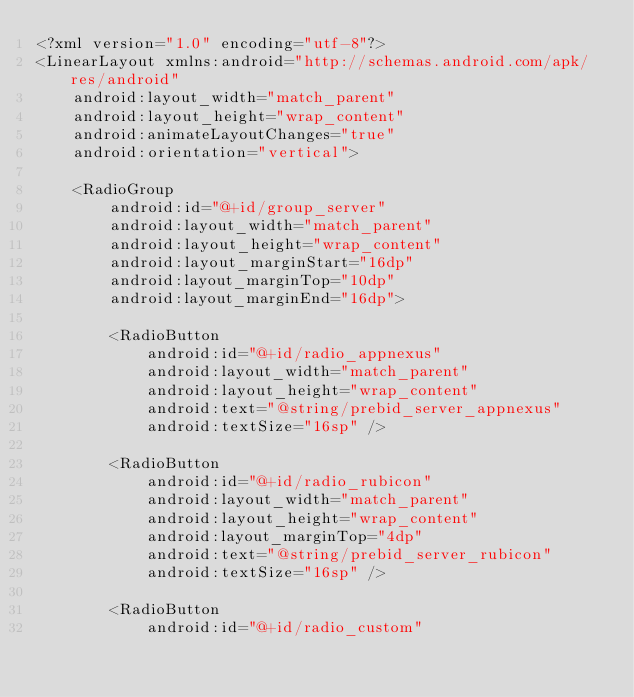Convert code to text. <code><loc_0><loc_0><loc_500><loc_500><_XML_><?xml version="1.0" encoding="utf-8"?>
<LinearLayout xmlns:android="http://schemas.android.com/apk/res/android"
    android:layout_width="match_parent"
    android:layout_height="wrap_content"
    android:animateLayoutChanges="true"
    android:orientation="vertical">

    <RadioGroup
        android:id="@+id/group_server"
        android:layout_width="match_parent"
        android:layout_height="wrap_content"
        android:layout_marginStart="16dp"
        android:layout_marginTop="10dp"
        android:layout_marginEnd="16dp">

        <RadioButton
            android:id="@+id/radio_appnexus"
            android:layout_width="match_parent"
            android:layout_height="wrap_content"
            android:text="@string/prebid_server_appnexus"
            android:textSize="16sp" />

        <RadioButton
            android:id="@+id/radio_rubicon"
            android:layout_width="match_parent"
            android:layout_height="wrap_content"
            android:layout_marginTop="4dp"
            android:text="@string/prebid_server_rubicon"
            android:textSize="16sp" />

        <RadioButton
            android:id="@+id/radio_custom"</code> 